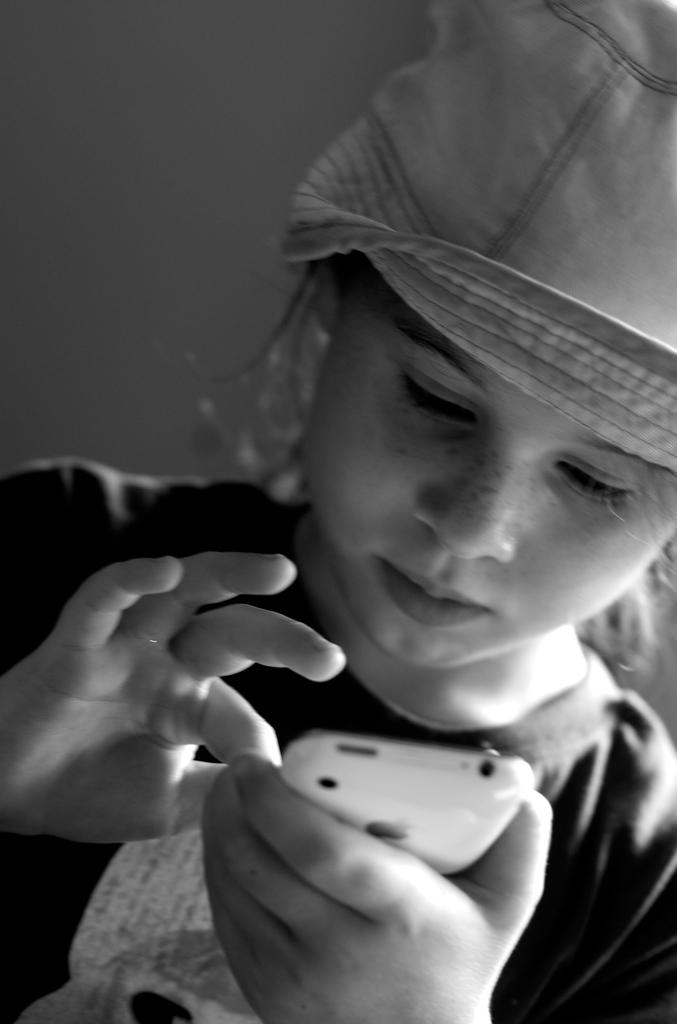What is the color scheme of the image? The image is black and white. Who is the main subject in the image? There is a girl in the image. What is the girl doing in the image? The girl is operating a mobile phone. How is the girl holding the mobile phone? The girl is holding the mobile phone in her hand. What type of paste is the girl using to stick the rail to the wall in the image? There is no paste or rail present in the image; it features a girl holding a mobile phone. 